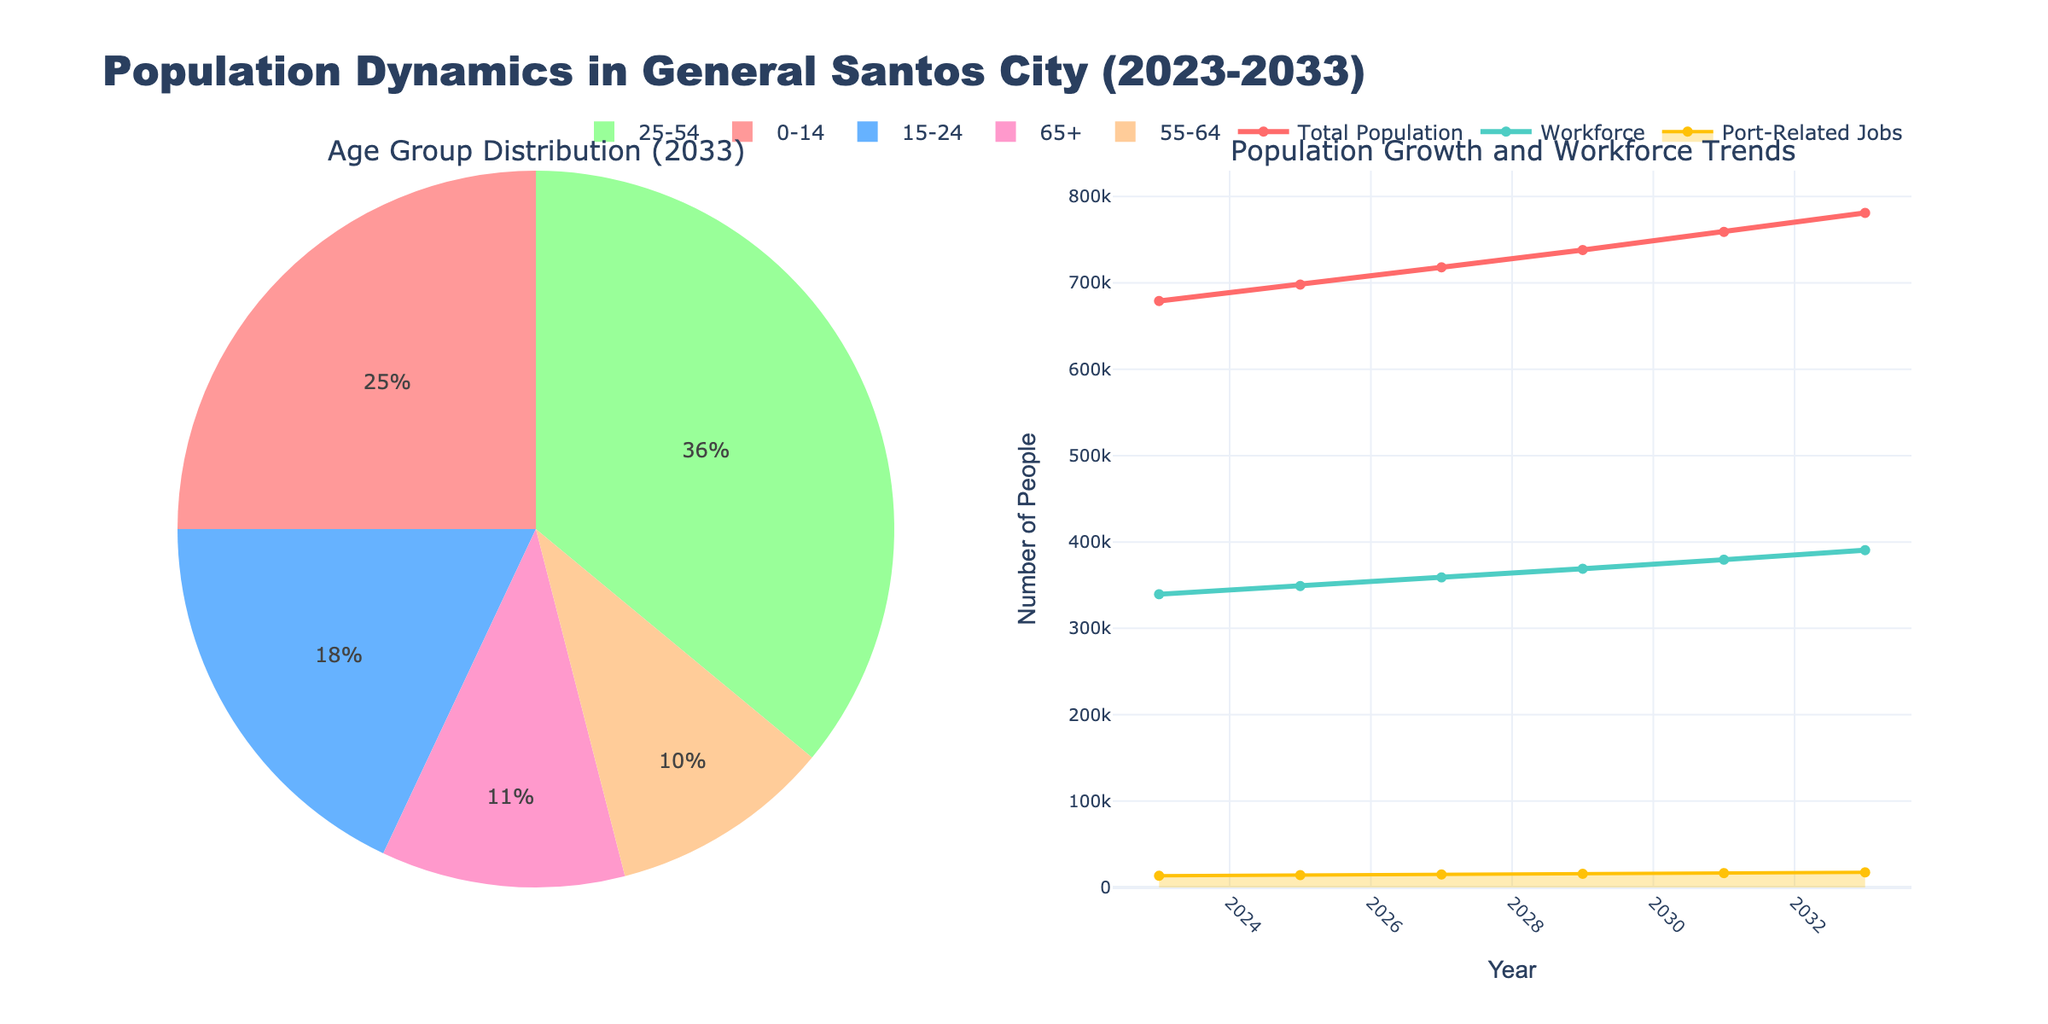What is the title of the figure? The title is displayed prominently at the top of the figure, and it reads "Population Dynamics in General Santos City (2023-2033)."
Answer: Population Dynamics in General Santos City (2023-2033) How many years are displayed in the figure? We can count the tick marks along the x-axis in the line chart to determine the number of years covered.
Answer: 6 What is the age group distribution in 2033? The pie chart displays the percentages for each age group in the year 2033. The values can be read directly from the pie chart.
Answer: 0-14: 195250, 15-24: 140580, 25-54: 281160, 55-64: 78100, 65+: 85910 What is the total population in 2023? The total population for each year is plotted as a line graph, and you can read the value from the y-axis at the year 2023.
Answer: 679000 How does the workforce change from 2023 to 2033? The workforce data is also plotted as a line graph, and comparing the values at the years 2023 and 2033 will show the change.
Answer: Increases from 339500 to 390500 Compare the population and workforce trends over the years. By examining the line graphs for total population and workforce, we observe how each has progressed, noting the general upward trend for both and their relative rates of increase.
Answer: Both trends increase steadily, with the population growing slightly faster than the workforce What is the range of port-related jobs over the given years? By looking at the area chart for port-related jobs, identify the minimum and maximum values from the y-axis.
Answer: Range from 13580 to 17480 Which age group has the largest population in 2033? The pie chart for the year 2033 enables us to compare the sizes of the age groups.
Answer: 25-54 What is the predicted number of people in the 25-54 age group in 2029? This can be read directly from the dataframe provided, by locating the year 2029 and the corresponding value under the 25-54 column.
Answer: 265680 